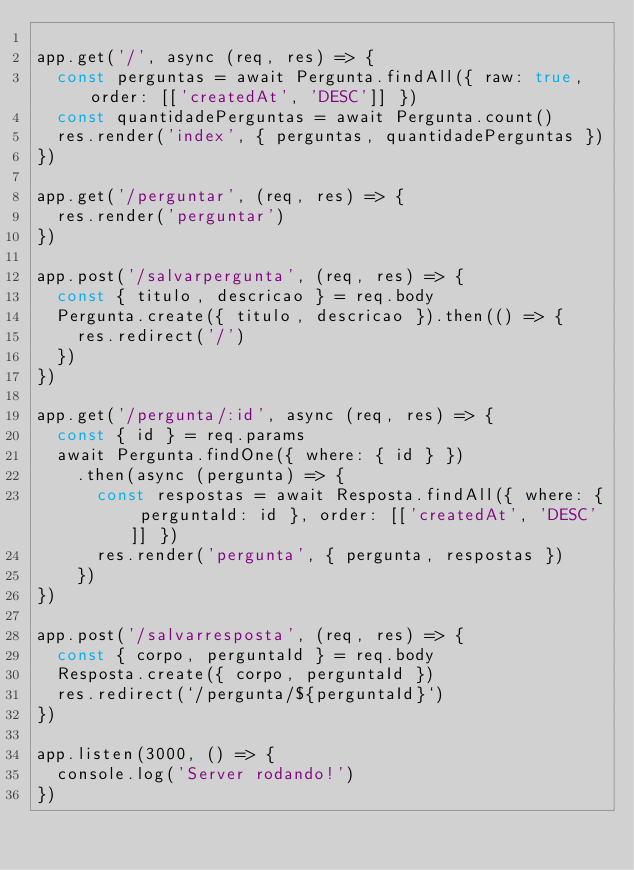Convert code to text. <code><loc_0><loc_0><loc_500><loc_500><_JavaScript_>
app.get('/', async (req, res) => {
  const perguntas = await Pergunta.findAll({ raw: true, order: [['createdAt', 'DESC']] })
  const quantidadePerguntas = await Pergunta.count()
  res.render('index', { perguntas, quantidadePerguntas })
})

app.get('/perguntar', (req, res) => {
  res.render('perguntar')
})

app.post('/salvarpergunta', (req, res) => {
  const { titulo, descricao } = req.body
  Pergunta.create({ titulo, descricao }).then(() => {
    res.redirect('/')
  })
})

app.get('/pergunta/:id', async (req, res) => {
  const { id } = req.params
  await Pergunta.findOne({ where: { id } })
    .then(async (pergunta) => {
      const respostas = await Resposta.findAll({ where: { perguntaId: id }, order: [['createdAt', 'DESC']] })
      res.render('pergunta', { pergunta, respostas })
    })
})

app.post('/salvarresposta', (req, res) => {
  const { corpo, perguntaId } = req.body
  Resposta.create({ corpo, perguntaId })
  res.redirect(`/pergunta/${perguntaId}`)
})

app.listen(3000, () => {
  console.log('Server rodando!')
})</code> 